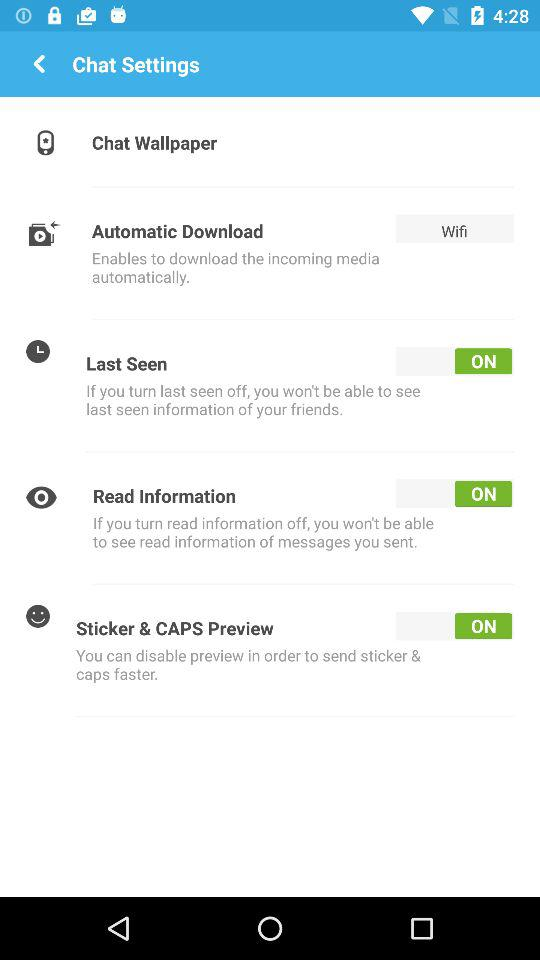What is the status of "Last Seen"? The status is "on". 